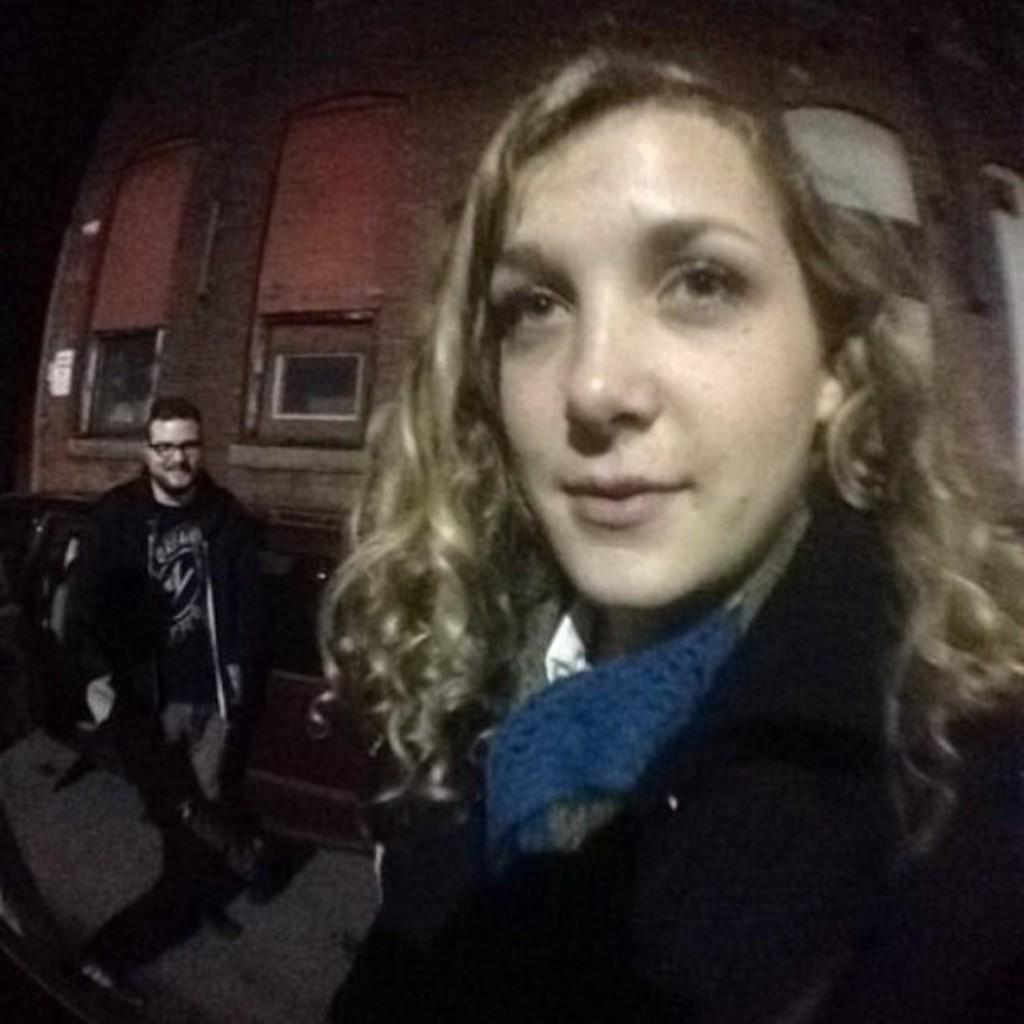How many people are present in the image? There are two persons in the image. What else can be seen in the image besides the people? There is a vehicle and a building visible in the image. Can you describe the time of day when the image was taken? The image was taken during nighttime. What type of waves can be seen crashing against the building in the image? There are no waves present in the image, as it was taken during nighttime and does not depict a coastal or beach setting. 